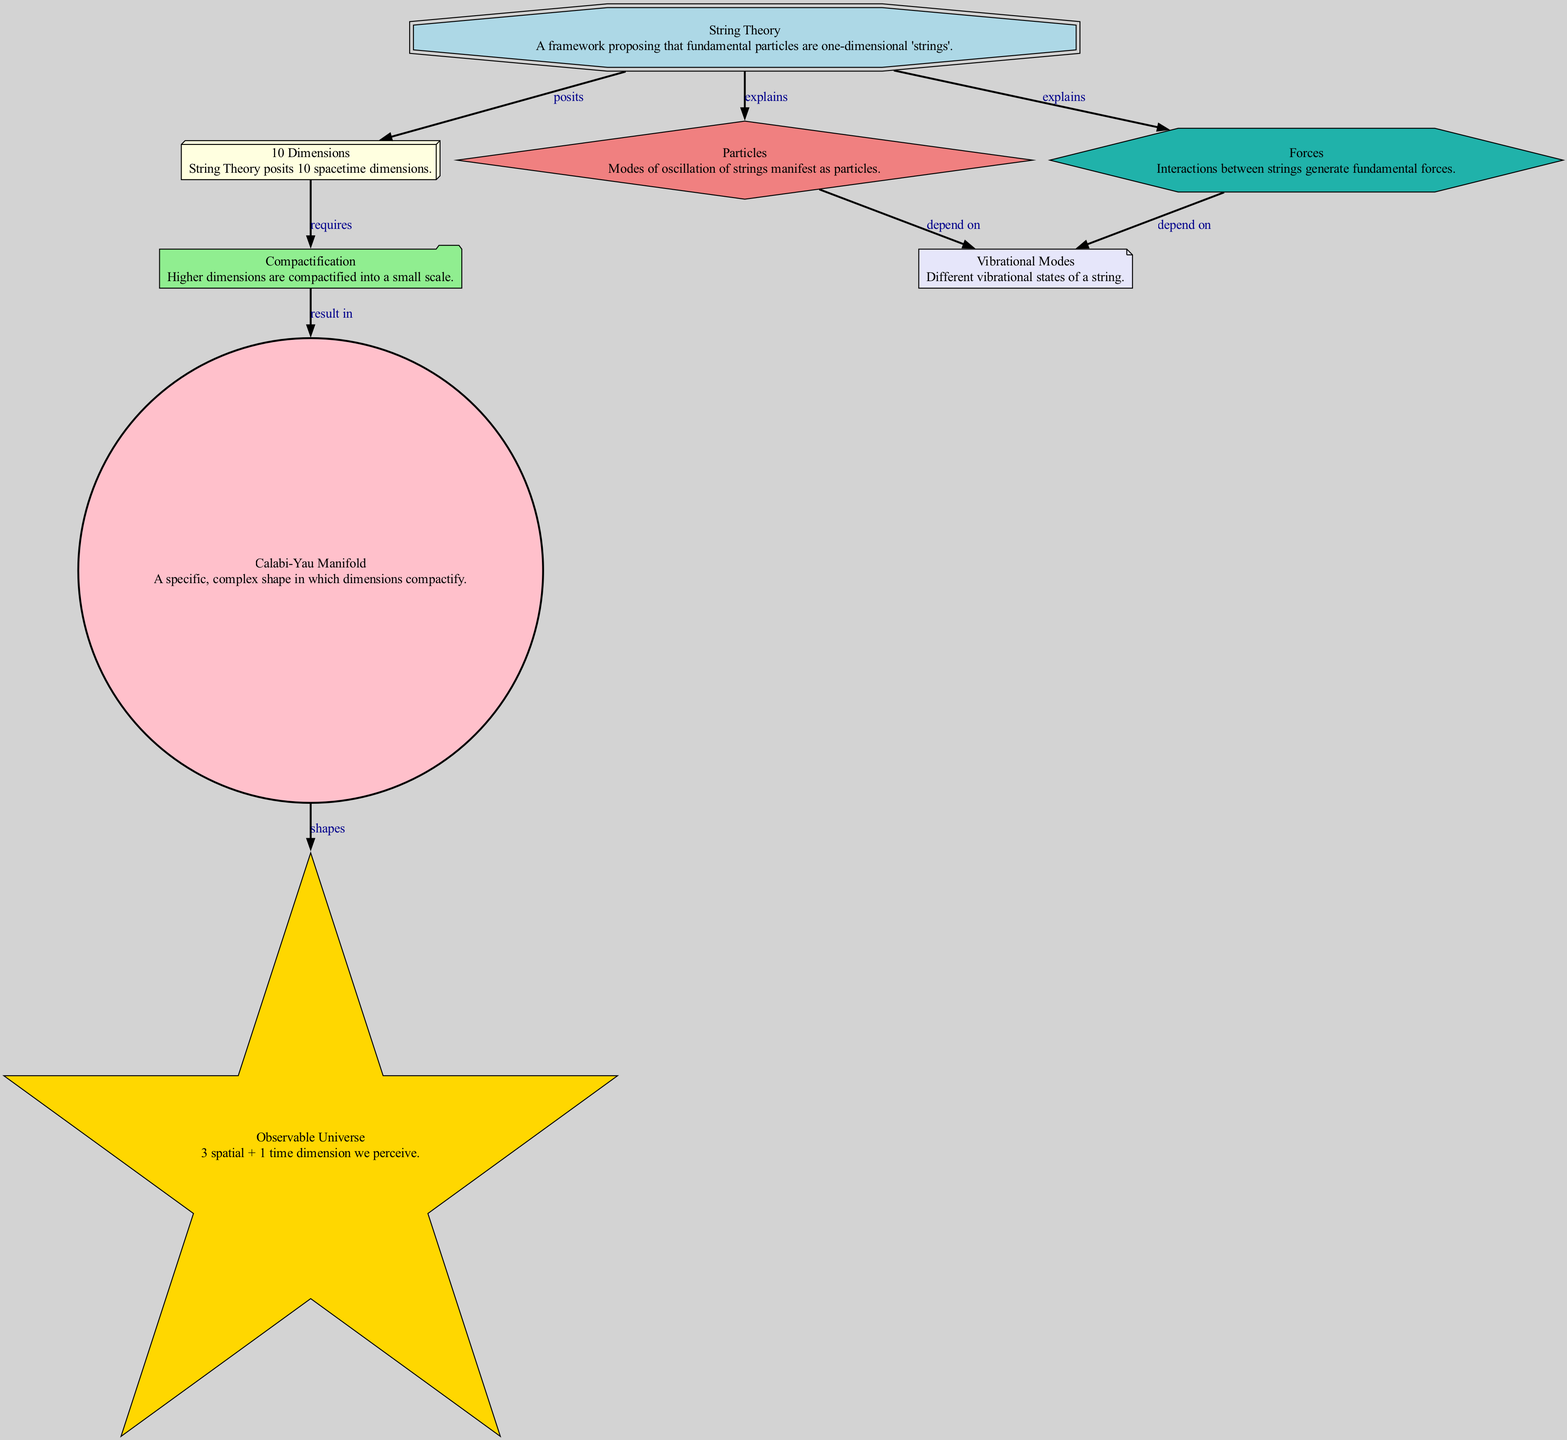What is the total number of nodes in the diagram? The diagram contains eight distinct nodes labeled as 'String Theory', '10 Dimensions', 'Compactification', 'Calabi-Yau Manifold', 'Observable Universe', 'Particles', 'Forces', and 'Vibrational Modes'.
Answer: 8 Which node explains the fundamental particles? The edge labeled "explains" from 'String Theory' leads to the node 'Particles'. Thus, 'String Theory' is the node that explains fundamental particles.
Answer: String Theory What relationship exists between 'Compactification' and 'Calabi-Yau Manifold'? The diagram shows that 'Compactification' results in the 'Calabi-Yau Manifold', indicating a direct relationship where the compactification process leads to this specific geometric structure.
Answer: results in What does '10 Dimensions' require? The edge labeled "requires" connects '10 Dimensions' to 'Compactification', meaning that '10 Dimensions' requires the process of Compactification.
Answer: Compactification How many observable dimensions do we have according to the diagram? The node 'Observable Universe' describes that we perceive 3 spatial dimensions plus 1 time dimension, totaling to four observable dimensions.
Answer: 4 What shapes the 'Observable Universe'? The edge shows that the 'Calabi-Yau Manifold' shapes the 'Observable Universe', indicating the geometric influence of the Calabi-Yau shape on the observable dimensions.
Answer: shapes What depends on the vibrational modes of strings? Both 'Particles' and 'Forces' are shown to depend on the 'Vibrational Modes', indicating that these fundamental aspects of physics derive from the different states of string vibration.
Answer: depend on Which node includes the phrase "fundamental forces"? The node labeled 'Forces' directly addresses fundamental forces, as evidenced by its description alongside its position in the diagram.
Answer: Forces What does 'String Theory' posit about dimensions? The edge shows that 'String Theory' posits '10 Dimensions', directly attributing this statistical value to string theory's hypothesis.
Answer: 10 Dimensions 